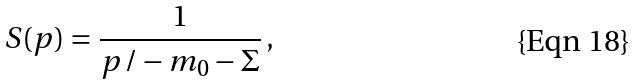Convert formula to latex. <formula><loc_0><loc_0><loc_500><loc_500>S ( p ) = \frac { 1 } { p \, / - m _ { 0 } - \Sigma } \, ,</formula> 